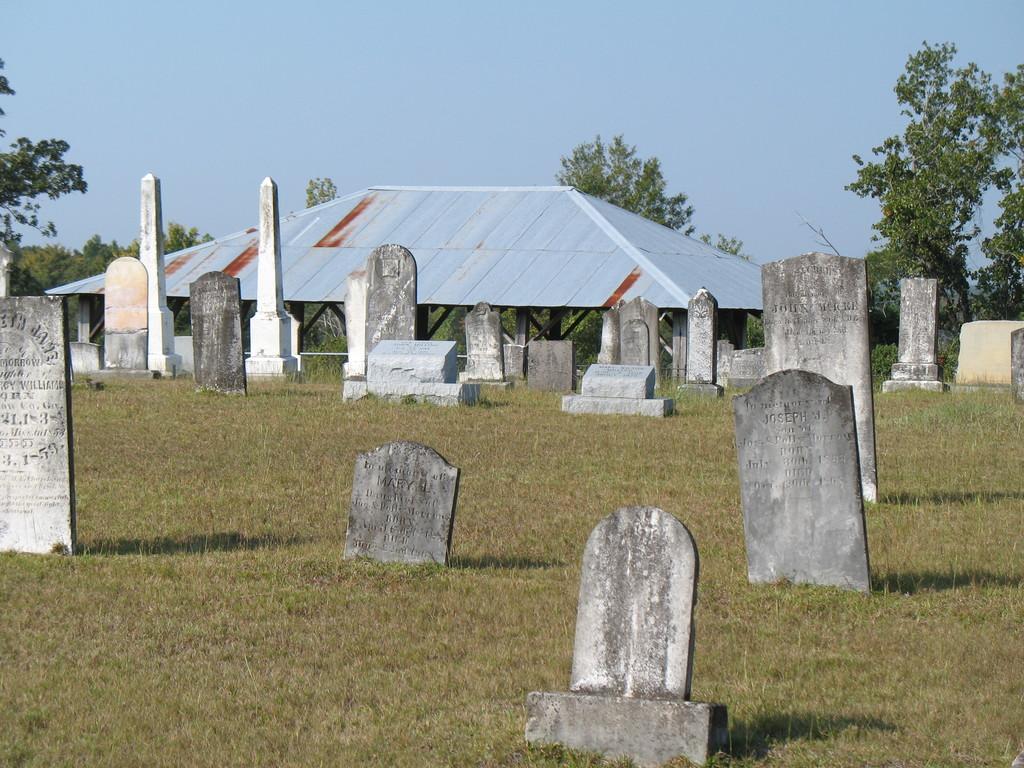Can you describe this image briefly? In this image we can see graves. On the ground there is grass. In the back there is a shed. Also there are trees. In the background there is sky. 